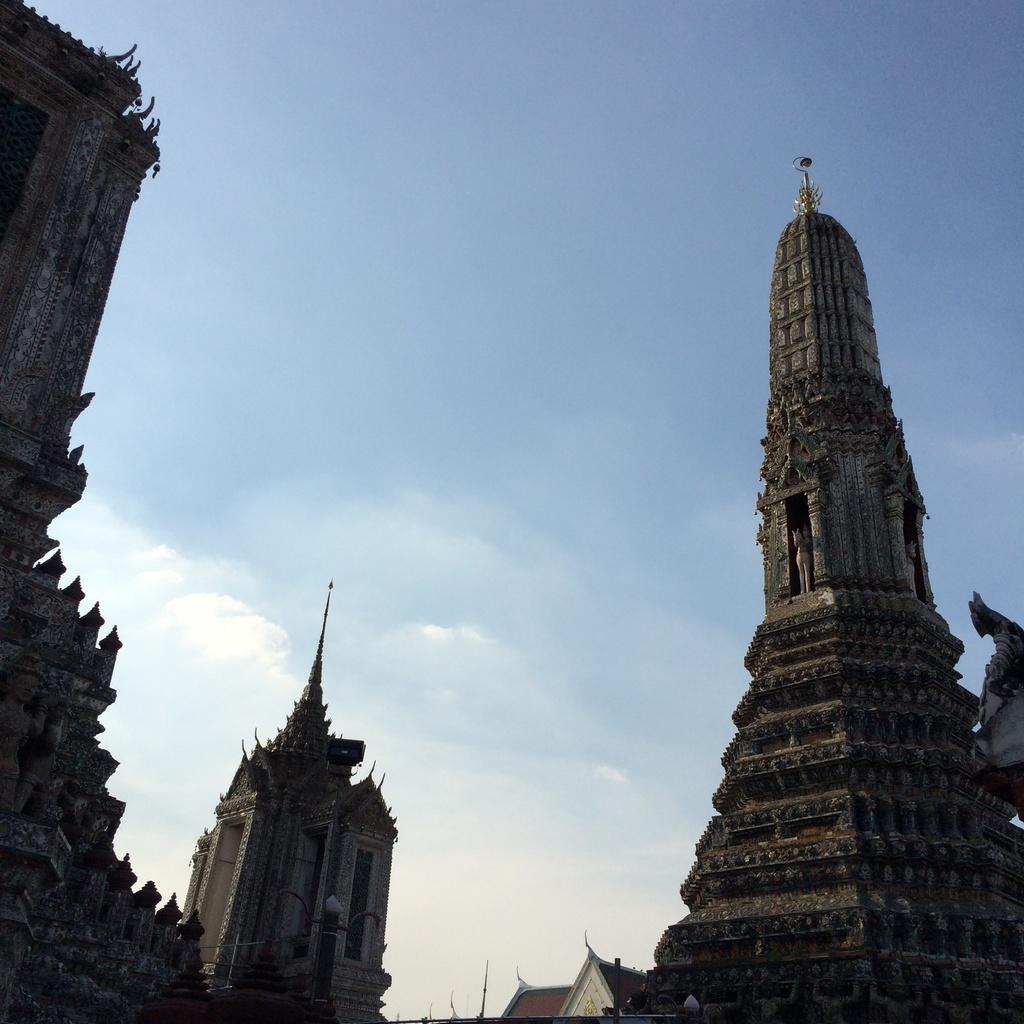What type of structures are featured in the image? There are buildings with sculptures and statues in the image. What can be seen in the background of the image? Sky is visible in the background of the image. What is the condition of the sky in the image? Clouds are present in the sky. Can you tell me how many planes are flying in the image? There are no planes visible in the image; it only features buildings with sculptures and statues, and the sky with clouds. What type of furniture is present in the image? There is no furniture, such as a desk, present in the image. 